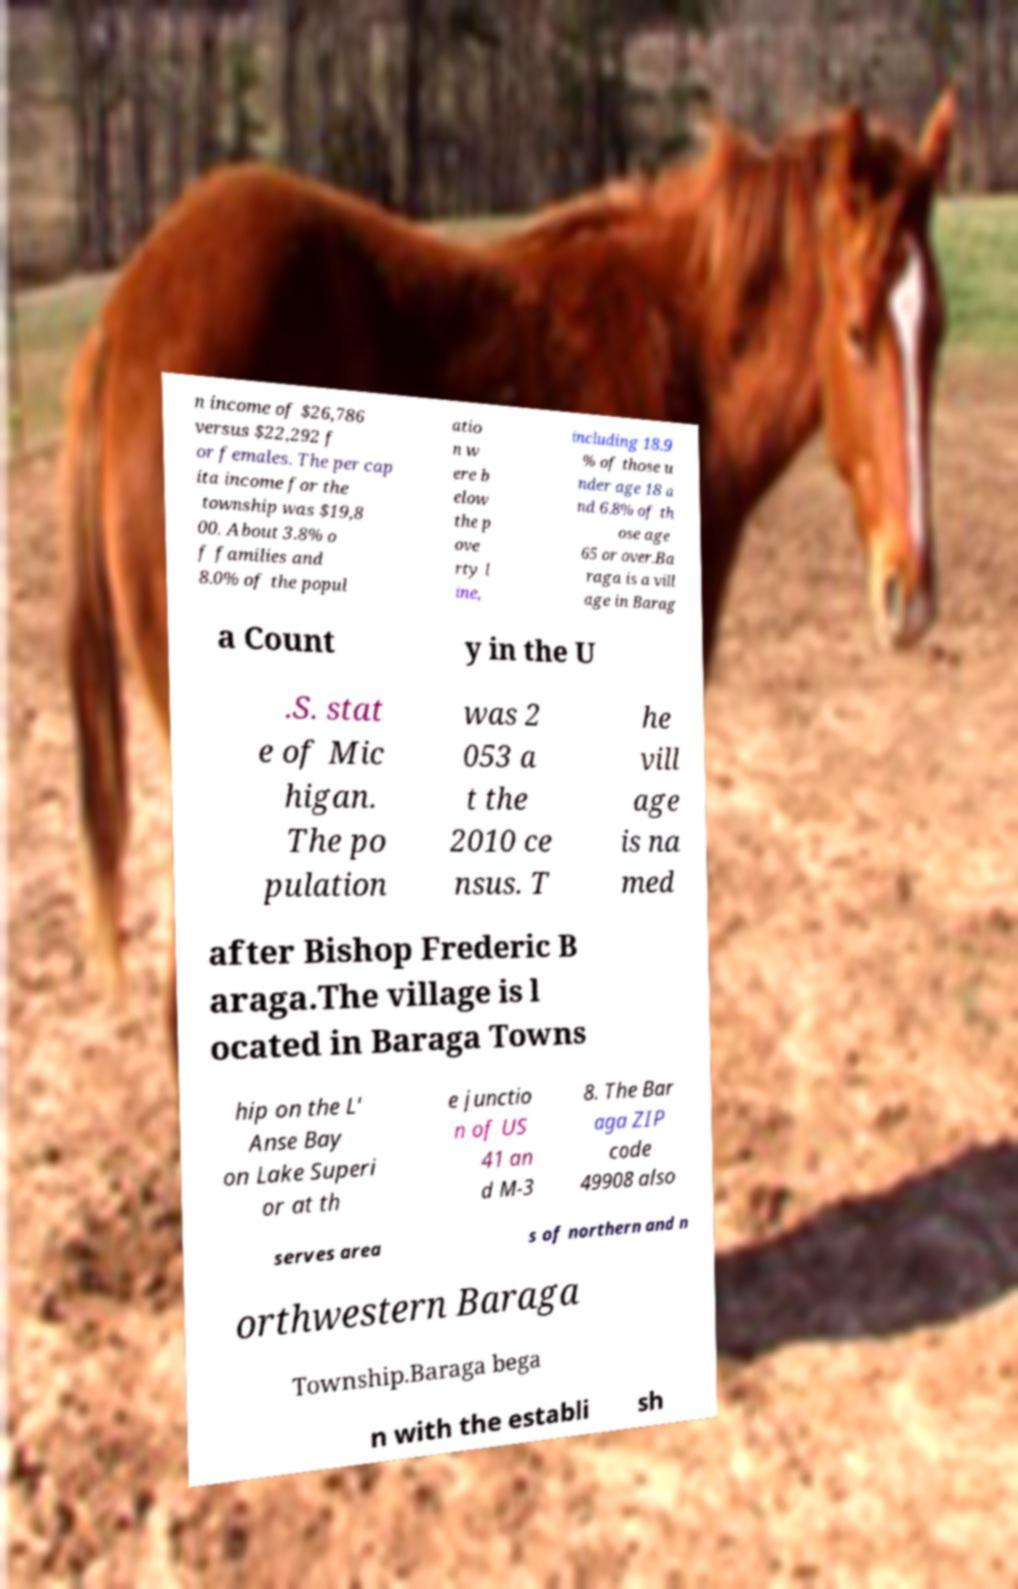What messages or text are displayed in this image? I need them in a readable, typed format. n income of $26,786 versus $22,292 f or females. The per cap ita income for the township was $19,8 00. About 3.8% o f families and 8.0% of the popul atio n w ere b elow the p ove rty l ine, including 18.9 % of those u nder age 18 a nd 6.8% of th ose age 65 or over.Ba raga is a vill age in Barag a Count y in the U .S. stat e of Mic higan. The po pulation was 2 053 a t the 2010 ce nsus. T he vill age is na med after Bishop Frederic B araga.The village is l ocated in Baraga Towns hip on the L' Anse Bay on Lake Superi or at th e junctio n of US 41 an d M-3 8. The Bar aga ZIP code 49908 also serves area s of northern and n orthwestern Baraga Township.Baraga bega n with the establi sh 